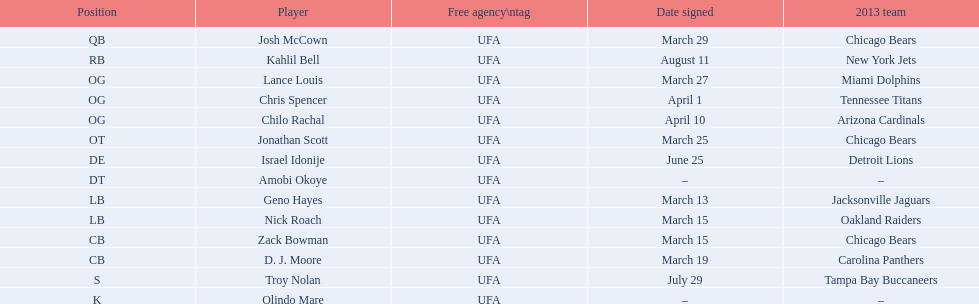What are all the dates signed? March 29, August 11, March 27, April 1, April 10, March 25, June 25, March 13, March 15, March 15, March 19, July 29. Which of these are duplicates? March 15, March 15. Who has the same one as nick roach? Zack Bowman. 